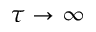<formula> <loc_0><loc_0><loc_500><loc_500>\tau \to \infty</formula> 